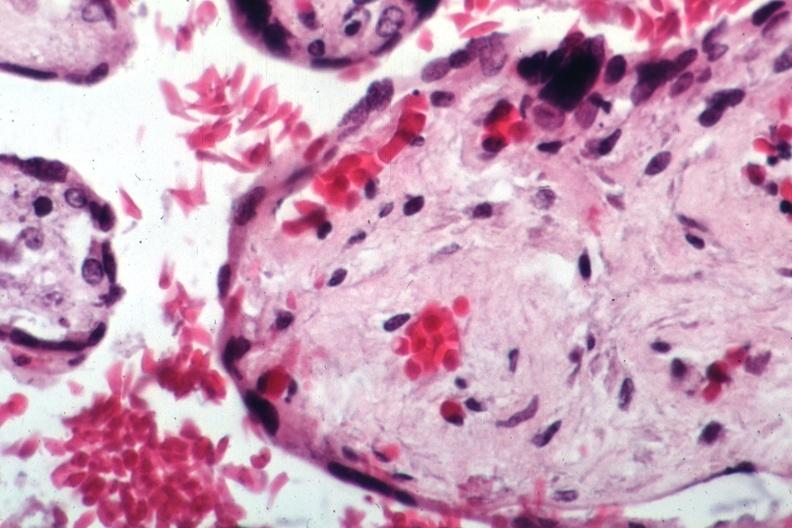where is this from?
Answer the question using a single word or phrase. Female reproductive system 